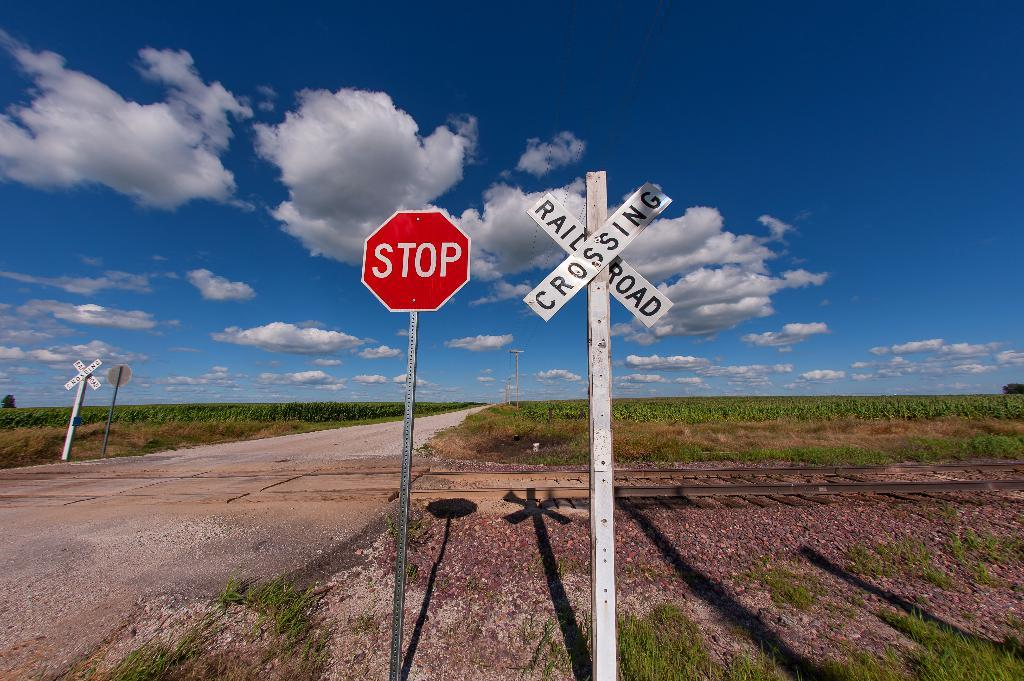<image>
Relay a brief, clear account of the picture shown. A stop sign and a railroad crossing sign next to each other. 